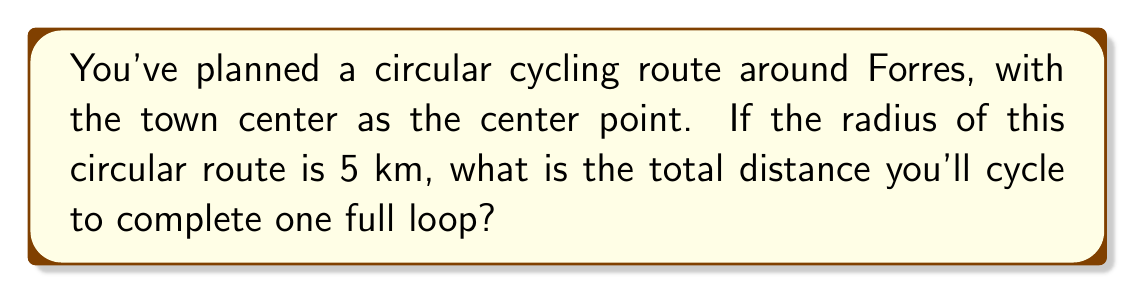Show me your answer to this math problem. To find the total distance of a circular cycling route, we need to calculate the circumference of the circle. The formula for the circumference of a circle is:

$$C = 2\pi r$$

Where:
$C$ = circumference
$\pi$ = pi (approximately 3.14159)
$r$ = radius

Given:
$r = 5$ km

Let's substitute these values into the formula:

$$C = 2\pi (5)$$
$$C = 10\pi$$

To get a numerical value, we can use 3.14159 as an approximation for $\pi$:

$$C \approx 10 * 3.14159$$
$$C \approx 31.4159$$ km

Rounding to two decimal places for practical purposes:

$$C \approx 31.42$$ km

Therefore, the total distance of the circular cycling route is approximately 31.42 km.
Answer: $31.42$ km 